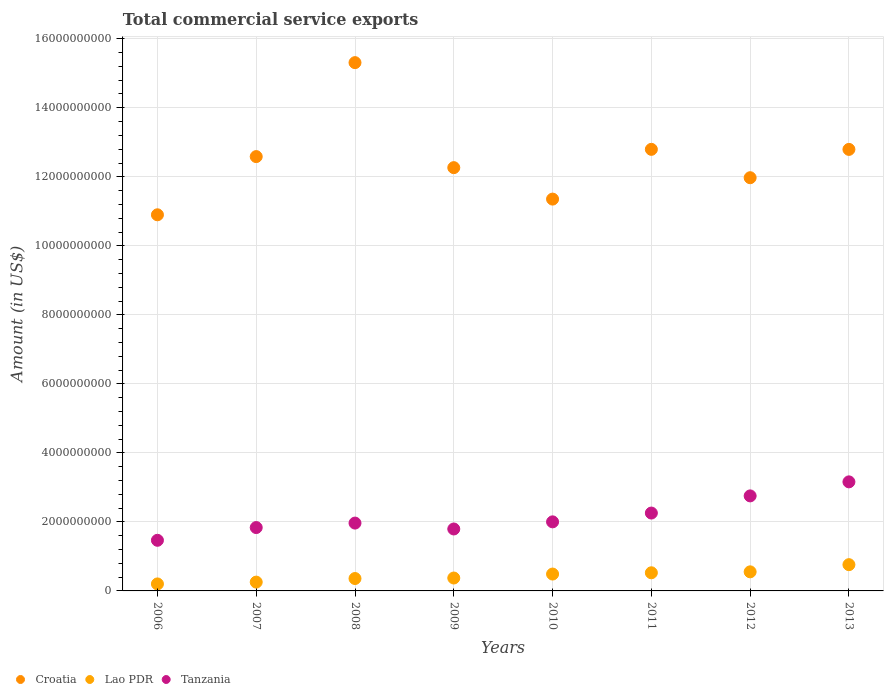Is the number of dotlines equal to the number of legend labels?
Keep it short and to the point. Yes. What is the total commercial service exports in Croatia in 2010?
Keep it short and to the point. 1.14e+1. Across all years, what is the maximum total commercial service exports in Lao PDR?
Offer a terse response. 7.61e+08. Across all years, what is the minimum total commercial service exports in Lao PDR?
Make the answer very short. 2.03e+08. In which year was the total commercial service exports in Lao PDR maximum?
Your answer should be very brief. 2013. In which year was the total commercial service exports in Tanzania minimum?
Your answer should be very brief. 2006. What is the total total commercial service exports in Tanzania in the graph?
Offer a very short reply. 1.72e+1. What is the difference between the total commercial service exports in Lao PDR in 2008 and that in 2010?
Keep it short and to the point. -1.29e+08. What is the difference between the total commercial service exports in Tanzania in 2007 and the total commercial service exports in Lao PDR in 2009?
Provide a short and direct response. 1.46e+09. What is the average total commercial service exports in Croatia per year?
Your answer should be very brief. 1.25e+1. In the year 2012, what is the difference between the total commercial service exports in Lao PDR and total commercial service exports in Croatia?
Offer a terse response. -1.14e+1. What is the ratio of the total commercial service exports in Tanzania in 2009 to that in 2010?
Offer a terse response. 0.9. Is the difference between the total commercial service exports in Lao PDR in 2006 and 2013 greater than the difference between the total commercial service exports in Croatia in 2006 and 2013?
Keep it short and to the point. Yes. What is the difference between the highest and the second highest total commercial service exports in Lao PDR?
Offer a terse response. 2.08e+08. What is the difference between the highest and the lowest total commercial service exports in Lao PDR?
Your response must be concise. 5.58e+08. Is the sum of the total commercial service exports in Lao PDR in 2006 and 2008 greater than the maximum total commercial service exports in Croatia across all years?
Give a very brief answer. No. Is it the case that in every year, the sum of the total commercial service exports in Croatia and total commercial service exports in Lao PDR  is greater than the total commercial service exports in Tanzania?
Keep it short and to the point. Yes. Is the total commercial service exports in Lao PDR strictly greater than the total commercial service exports in Croatia over the years?
Offer a very short reply. No. Is the total commercial service exports in Croatia strictly less than the total commercial service exports in Tanzania over the years?
Offer a very short reply. No. How many years are there in the graph?
Keep it short and to the point. 8. Are the values on the major ticks of Y-axis written in scientific E-notation?
Your response must be concise. No. Does the graph contain any zero values?
Offer a terse response. No. Does the graph contain grids?
Provide a short and direct response. Yes. What is the title of the graph?
Offer a very short reply. Total commercial service exports. What is the label or title of the X-axis?
Give a very brief answer. Years. What is the Amount (in US$) of Croatia in 2006?
Offer a very short reply. 1.09e+1. What is the Amount (in US$) of Lao PDR in 2006?
Offer a very short reply. 2.03e+08. What is the Amount (in US$) in Tanzania in 2006?
Provide a short and direct response. 1.47e+09. What is the Amount (in US$) of Croatia in 2007?
Keep it short and to the point. 1.26e+1. What is the Amount (in US$) in Lao PDR in 2007?
Offer a very short reply. 2.55e+08. What is the Amount (in US$) in Tanzania in 2007?
Give a very brief answer. 1.84e+09. What is the Amount (in US$) in Croatia in 2008?
Offer a terse response. 1.53e+1. What is the Amount (in US$) of Lao PDR in 2008?
Keep it short and to the point. 3.59e+08. What is the Amount (in US$) in Tanzania in 2008?
Your answer should be very brief. 1.97e+09. What is the Amount (in US$) in Croatia in 2009?
Provide a succinct answer. 1.23e+1. What is the Amount (in US$) in Lao PDR in 2009?
Your response must be concise. 3.74e+08. What is the Amount (in US$) in Tanzania in 2009?
Keep it short and to the point. 1.79e+09. What is the Amount (in US$) of Croatia in 2010?
Offer a terse response. 1.14e+1. What is the Amount (in US$) of Lao PDR in 2010?
Give a very brief answer. 4.89e+08. What is the Amount (in US$) of Tanzania in 2010?
Provide a succinct answer. 2.00e+09. What is the Amount (in US$) of Croatia in 2011?
Provide a short and direct response. 1.28e+1. What is the Amount (in US$) of Lao PDR in 2011?
Give a very brief answer. 5.26e+08. What is the Amount (in US$) of Tanzania in 2011?
Ensure brevity in your answer.  2.26e+09. What is the Amount (in US$) in Croatia in 2012?
Offer a terse response. 1.20e+1. What is the Amount (in US$) of Lao PDR in 2012?
Your answer should be compact. 5.53e+08. What is the Amount (in US$) in Tanzania in 2012?
Your response must be concise. 2.75e+09. What is the Amount (in US$) in Croatia in 2013?
Give a very brief answer. 1.28e+1. What is the Amount (in US$) in Lao PDR in 2013?
Provide a succinct answer. 7.61e+08. What is the Amount (in US$) in Tanzania in 2013?
Keep it short and to the point. 3.16e+09. Across all years, what is the maximum Amount (in US$) in Croatia?
Provide a succinct answer. 1.53e+1. Across all years, what is the maximum Amount (in US$) of Lao PDR?
Keep it short and to the point. 7.61e+08. Across all years, what is the maximum Amount (in US$) of Tanzania?
Offer a very short reply. 3.16e+09. Across all years, what is the minimum Amount (in US$) of Croatia?
Provide a succinct answer. 1.09e+1. Across all years, what is the minimum Amount (in US$) of Lao PDR?
Give a very brief answer. 2.03e+08. Across all years, what is the minimum Amount (in US$) of Tanzania?
Your response must be concise. 1.47e+09. What is the total Amount (in US$) in Croatia in the graph?
Provide a succinct answer. 1.00e+11. What is the total Amount (in US$) in Lao PDR in the graph?
Keep it short and to the point. 3.52e+09. What is the total Amount (in US$) in Tanzania in the graph?
Your answer should be very brief. 1.72e+1. What is the difference between the Amount (in US$) of Croatia in 2006 and that in 2007?
Keep it short and to the point. -1.69e+09. What is the difference between the Amount (in US$) in Lao PDR in 2006 and that in 2007?
Offer a very short reply. -5.27e+07. What is the difference between the Amount (in US$) in Tanzania in 2006 and that in 2007?
Your answer should be very brief. -3.69e+08. What is the difference between the Amount (in US$) in Croatia in 2006 and that in 2008?
Provide a short and direct response. -4.41e+09. What is the difference between the Amount (in US$) in Lao PDR in 2006 and that in 2008?
Keep it short and to the point. -1.57e+08. What is the difference between the Amount (in US$) of Tanzania in 2006 and that in 2008?
Provide a short and direct response. -4.99e+08. What is the difference between the Amount (in US$) in Croatia in 2006 and that in 2009?
Offer a very short reply. -1.37e+09. What is the difference between the Amount (in US$) in Lao PDR in 2006 and that in 2009?
Your response must be concise. -1.71e+08. What is the difference between the Amount (in US$) in Tanzania in 2006 and that in 2009?
Your answer should be compact. -3.28e+08. What is the difference between the Amount (in US$) in Croatia in 2006 and that in 2010?
Make the answer very short. -4.55e+08. What is the difference between the Amount (in US$) in Lao PDR in 2006 and that in 2010?
Provide a short and direct response. -2.86e+08. What is the difference between the Amount (in US$) of Tanzania in 2006 and that in 2010?
Give a very brief answer. -5.34e+08. What is the difference between the Amount (in US$) of Croatia in 2006 and that in 2011?
Ensure brevity in your answer.  -1.90e+09. What is the difference between the Amount (in US$) of Lao PDR in 2006 and that in 2011?
Ensure brevity in your answer.  -3.23e+08. What is the difference between the Amount (in US$) in Tanzania in 2006 and that in 2011?
Provide a short and direct response. -7.89e+08. What is the difference between the Amount (in US$) in Croatia in 2006 and that in 2012?
Make the answer very short. -1.07e+09. What is the difference between the Amount (in US$) in Lao PDR in 2006 and that in 2012?
Offer a very short reply. -3.50e+08. What is the difference between the Amount (in US$) in Tanzania in 2006 and that in 2012?
Offer a very short reply. -1.29e+09. What is the difference between the Amount (in US$) in Croatia in 2006 and that in 2013?
Your answer should be very brief. -1.90e+09. What is the difference between the Amount (in US$) in Lao PDR in 2006 and that in 2013?
Keep it short and to the point. -5.58e+08. What is the difference between the Amount (in US$) of Tanzania in 2006 and that in 2013?
Offer a terse response. -1.69e+09. What is the difference between the Amount (in US$) of Croatia in 2007 and that in 2008?
Offer a very short reply. -2.72e+09. What is the difference between the Amount (in US$) in Lao PDR in 2007 and that in 2008?
Offer a very short reply. -1.04e+08. What is the difference between the Amount (in US$) of Tanzania in 2007 and that in 2008?
Offer a terse response. -1.29e+08. What is the difference between the Amount (in US$) of Croatia in 2007 and that in 2009?
Your response must be concise. 3.20e+08. What is the difference between the Amount (in US$) in Lao PDR in 2007 and that in 2009?
Provide a short and direct response. -1.19e+08. What is the difference between the Amount (in US$) in Tanzania in 2007 and that in 2009?
Ensure brevity in your answer.  4.15e+07. What is the difference between the Amount (in US$) of Croatia in 2007 and that in 2010?
Offer a very short reply. 1.23e+09. What is the difference between the Amount (in US$) of Lao PDR in 2007 and that in 2010?
Ensure brevity in your answer.  -2.33e+08. What is the difference between the Amount (in US$) of Tanzania in 2007 and that in 2010?
Keep it short and to the point. -1.65e+08. What is the difference between the Amount (in US$) in Croatia in 2007 and that in 2011?
Offer a terse response. -2.10e+08. What is the difference between the Amount (in US$) of Lao PDR in 2007 and that in 2011?
Your answer should be compact. -2.70e+08. What is the difference between the Amount (in US$) in Tanzania in 2007 and that in 2011?
Provide a succinct answer. -4.20e+08. What is the difference between the Amount (in US$) of Croatia in 2007 and that in 2012?
Keep it short and to the point. 6.12e+08. What is the difference between the Amount (in US$) in Lao PDR in 2007 and that in 2012?
Your answer should be very brief. -2.98e+08. What is the difference between the Amount (in US$) of Tanzania in 2007 and that in 2012?
Make the answer very short. -9.17e+08. What is the difference between the Amount (in US$) of Croatia in 2007 and that in 2013?
Give a very brief answer. -2.09e+08. What is the difference between the Amount (in US$) of Lao PDR in 2007 and that in 2013?
Ensure brevity in your answer.  -5.06e+08. What is the difference between the Amount (in US$) in Tanzania in 2007 and that in 2013?
Keep it short and to the point. -1.32e+09. What is the difference between the Amount (in US$) of Croatia in 2008 and that in 2009?
Give a very brief answer. 3.04e+09. What is the difference between the Amount (in US$) in Lao PDR in 2008 and that in 2009?
Ensure brevity in your answer.  -1.45e+07. What is the difference between the Amount (in US$) in Tanzania in 2008 and that in 2009?
Keep it short and to the point. 1.71e+08. What is the difference between the Amount (in US$) in Croatia in 2008 and that in 2010?
Make the answer very short. 3.95e+09. What is the difference between the Amount (in US$) in Lao PDR in 2008 and that in 2010?
Make the answer very short. -1.29e+08. What is the difference between the Amount (in US$) in Tanzania in 2008 and that in 2010?
Offer a terse response. -3.58e+07. What is the difference between the Amount (in US$) of Croatia in 2008 and that in 2011?
Offer a terse response. 2.51e+09. What is the difference between the Amount (in US$) in Lao PDR in 2008 and that in 2011?
Your answer should be compact. -1.66e+08. What is the difference between the Amount (in US$) in Tanzania in 2008 and that in 2011?
Ensure brevity in your answer.  -2.91e+08. What is the difference between the Amount (in US$) in Croatia in 2008 and that in 2012?
Provide a succinct answer. 3.33e+09. What is the difference between the Amount (in US$) in Lao PDR in 2008 and that in 2012?
Offer a terse response. -1.94e+08. What is the difference between the Amount (in US$) of Tanzania in 2008 and that in 2012?
Ensure brevity in your answer.  -7.88e+08. What is the difference between the Amount (in US$) in Croatia in 2008 and that in 2013?
Provide a succinct answer. 2.51e+09. What is the difference between the Amount (in US$) of Lao PDR in 2008 and that in 2013?
Provide a short and direct response. -4.02e+08. What is the difference between the Amount (in US$) in Tanzania in 2008 and that in 2013?
Keep it short and to the point. -1.19e+09. What is the difference between the Amount (in US$) of Croatia in 2009 and that in 2010?
Offer a very short reply. 9.11e+08. What is the difference between the Amount (in US$) in Lao PDR in 2009 and that in 2010?
Keep it short and to the point. -1.15e+08. What is the difference between the Amount (in US$) of Tanzania in 2009 and that in 2010?
Your answer should be compact. -2.07e+08. What is the difference between the Amount (in US$) of Croatia in 2009 and that in 2011?
Keep it short and to the point. -5.30e+08. What is the difference between the Amount (in US$) in Lao PDR in 2009 and that in 2011?
Provide a succinct answer. -1.52e+08. What is the difference between the Amount (in US$) of Tanzania in 2009 and that in 2011?
Your answer should be very brief. -4.62e+08. What is the difference between the Amount (in US$) of Croatia in 2009 and that in 2012?
Make the answer very short. 2.92e+08. What is the difference between the Amount (in US$) in Lao PDR in 2009 and that in 2012?
Give a very brief answer. -1.79e+08. What is the difference between the Amount (in US$) in Tanzania in 2009 and that in 2012?
Make the answer very short. -9.59e+08. What is the difference between the Amount (in US$) in Croatia in 2009 and that in 2013?
Offer a terse response. -5.29e+08. What is the difference between the Amount (in US$) in Lao PDR in 2009 and that in 2013?
Ensure brevity in your answer.  -3.87e+08. What is the difference between the Amount (in US$) of Tanzania in 2009 and that in 2013?
Offer a very short reply. -1.37e+09. What is the difference between the Amount (in US$) in Croatia in 2010 and that in 2011?
Offer a terse response. -1.44e+09. What is the difference between the Amount (in US$) in Lao PDR in 2010 and that in 2011?
Keep it short and to the point. -3.68e+07. What is the difference between the Amount (in US$) of Tanzania in 2010 and that in 2011?
Your answer should be very brief. -2.55e+08. What is the difference between the Amount (in US$) of Croatia in 2010 and that in 2012?
Offer a terse response. -6.20e+08. What is the difference between the Amount (in US$) in Lao PDR in 2010 and that in 2012?
Your answer should be very brief. -6.41e+07. What is the difference between the Amount (in US$) in Tanzania in 2010 and that in 2012?
Your answer should be compact. -7.52e+08. What is the difference between the Amount (in US$) of Croatia in 2010 and that in 2013?
Offer a very short reply. -1.44e+09. What is the difference between the Amount (in US$) in Lao PDR in 2010 and that in 2013?
Give a very brief answer. -2.72e+08. What is the difference between the Amount (in US$) of Tanzania in 2010 and that in 2013?
Offer a terse response. -1.16e+09. What is the difference between the Amount (in US$) of Croatia in 2011 and that in 2012?
Make the answer very short. 8.22e+08. What is the difference between the Amount (in US$) of Lao PDR in 2011 and that in 2012?
Offer a terse response. -2.74e+07. What is the difference between the Amount (in US$) of Tanzania in 2011 and that in 2012?
Offer a very short reply. -4.97e+08. What is the difference between the Amount (in US$) in Croatia in 2011 and that in 2013?
Keep it short and to the point. 1.49e+06. What is the difference between the Amount (in US$) of Lao PDR in 2011 and that in 2013?
Your answer should be compact. -2.35e+08. What is the difference between the Amount (in US$) in Tanzania in 2011 and that in 2013?
Your answer should be compact. -9.04e+08. What is the difference between the Amount (in US$) of Croatia in 2012 and that in 2013?
Offer a very short reply. -8.21e+08. What is the difference between the Amount (in US$) in Lao PDR in 2012 and that in 2013?
Keep it short and to the point. -2.08e+08. What is the difference between the Amount (in US$) of Tanzania in 2012 and that in 2013?
Your answer should be compact. -4.07e+08. What is the difference between the Amount (in US$) in Croatia in 2006 and the Amount (in US$) in Lao PDR in 2007?
Give a very brief answer. 1.06e+1. What is the difference between the Amount (in US$) in Croatia in 2006 and the Amount (in US$) in Tanzania in 2007?
Provide a succinct answer. 9.06e+09. What is the difference between the Amount (in US$) of Lao PDR in 2006 and the Amount (in US$) of Tanzania in 2007?
Make the answer very short. -1.63e+09. What is the difference between the Amount (in US$) of Croatia in 2006 and the Amount (in US$) of Lao PDR in 2008?
Provide a short and direct response. 1.05e+1. What is the difference between the Amount (in US$) in Croatia in 2006 and the Amount (in US$) in Tanzania in 2008?
Your response must be concise. 8.93e+09. What is the difference between the Amount (in US$) in Lao PDR in 2006 and the Amount (in US$) in Tanzania in 2008?
Make the answer very short. -1.76e+09. What is the difference between the Amount (in US$) in Croatia in 2006 and the Amount (in US$) in Lao PDR in 2009?
Your answer should be compact. 1.05e+1. What is the difference between the Amount (in US$) in Croatia in 2006 and the Amount (in US$) in Tanzania in 2009?
Offer a terse response. 9.10e+09. What is the difference between the Amount (in US$) of Lao PDR in 2006 and the Amount (in US$) of Tanzania in 2009?
Offer a terse response. -1.59e+09. What is the difference between the Amount (in US$) in Croatia in 2006 and the Amount (in US$) in Lao PDR in 2010?
Your answer should be very brief. 1.04e+1. What is the difference between the Amount (in US$) in Croatia in 2006 and the Amount (in US$) in Tanzania in 2010?
Offer a terse response. 8.90e+09. What is the difference between the Amount (in US$) of Lao PDR in 2006 and the Amount (in US$) of Tanzania in 2010?
Your answer should be compact. -1.80e+09. What is the difference between the Amount (in US$) of Croatia in 2006 and the Amount (in US$) of Lao PDR in 2011?
Provide a succinct answer. 1.04e+1. What is the difference between the Amount (in US$) of Croatia in 2006 and the Amount (in US$) of Tanzania in 2011?
Your answer should be compact. 8.64e+09. What is the difference between the Amount (in US$) of Lao PDR in 2006 and the Amount (in US$) of Tanzania in 2011?
Offer a very short reply. -2.05e+09. What is the difference between the Amount (in US$) of Croatia in 2006 and the Amount (in US$) of Lao PDR in 2012?
Give a very brief answer. 1.03e+1. What is the difference between the Amount (in US$) of Croatia in 2006 and the Amount (in US$) of Tanzania in 2012?
Ensure brevity in your answer.  8.15e+09. What is the difference between the Amount (in US$) in Lao PDR in 2006 and the Amount (in US$) in Tanzania in 2012?
Your answer should be compact. -2.55e+09. What is the difference between the Amount (in US$) in Croatia in 2006 and the Amount (in US$) in Lao PDR in 2013?
Offer a very short reply. 1.01e+1. What is the difference between the Amount (in US$) of Croatia in 2006 and the Amount (in US$) of Tanzania in 2013?
Your answer should be very brief. 7.74e+09. What is the difference between the Amount (in US$) of Lao PDR in 2006 and the Amount (in US$) of Tanzania in 2013?
Ensure brevity in your answer.  -2.96e+09. What is the difference between the Amount (in US$) of Croatia in 2007 and the Amount (in US$) of Lao PDR in 2008?
Provide a short and direct response. 1.22e+1. What is the difference between the Amount (in US$) in Croatia in 2007 and the Amount (in US$) in Tanzania in 2008?
Give a very brief answer. 1.06e+1. What is the difference between the Amount (in US$) in Lao PDR in 2007 and the Amount (in US$) in Tanzania in 2008?
Ensure brevity in your answer.  -1.71e+09. What is the difference between the Amount (in US$) of Croatia in 2007 and the Amount (in US$) of Lao PDR in 2009?
Give a very brief answer. 1.22e+1. What is the difference between the Amount (in US$) in Croatia in 2007 and the Amount (in US$) in Tanzania in 2009?
Your response must be concise. 1.08e+1. What is the difference between the Amount (in US$) of Lao PDR in 2007 and the Amount (in US$) of Tanzania in 2009?
Keep it short and to the point. -1.54e+09. What is the difference between the Amount (in US$) in Croatia in 2007 and the Amount (in US$) in Lao PDR in 2010?
Give a very brief answer. 1.21e+1. What is the difference between the Amount (in US$) in Croatia in 2007 and the Amount (in US$) in Tanzania in 2010?
Provide a short and direct response. 1.06e+1. What is the difference between the Amount (in US$) in Lao PDR in 2007 and the Amount (in US$) in Tanzania in 2010?
Provide a short and direct response. -1.75e+09. What is the difference between the Amount (in US$) of Croatia in 2007 and the Amount (in US$) of Lao PDR in 2011?
Give a very brief answer. 1.21e+1. What is the difference between the Amount (in US$) of Croatia in 2007 and the Amount (in US$) of Tanzania in 2011?
Make the answer very short. 1.03e+1. What is the difference between the Amount (in US$) in Lao PDR in 2007 and the Amount (in US$) in Tanzania in 2011?
Your answer should be compact. -2.00e+09. What is the difference between the Amount (in US$) of Croatia in 2007 and the Amount (in US$) of Lao PDR in 2012?
Give a very brief answer. 1.20e+1. What is the difference between the Amount (in US$) in Croatia in 2007 and the Amount (in US$) in Tanzania in 2012?
Your answer should be very brief. 9.83e+09. What is the difference between the Amount (in US$) of Lao PDR in 2007 and the Amount (in US$) of Tanzania in 2012?
Give a very brief answer. -2.50e+09. What is the difference between the Amount (in US$) in Croatia in 2007 and the Amount (in US$) in Lao PDR in 2013?
Make the answer very short. 1.18e+1. What is the difference between the Amount (in US$) of Croatia in 2007 and the Amount (in US$) of Tanzania in 2013?
Keep it short and to the point. 9.43e+09. What is the difference between the Amount (in US$) of Lao PDR in 2007 and the Amount (in US$) of Tanzania in 2013?
Your response must be concise. -2.90e+09. What is the difference between the Amount (in US$) of Croatia in 2008 and the Amount (in US$) of Lao PDR in 2009?
Provide a short and direct response. 1.49e+1. What is the difference between the Amount (in US$) in Croatia in 2008 and the Amount (in US$) in Tanzania in 2009?
Ensure brevity in your answer.  1.35e+1. What is the difference between the Amount (in US$) in Lao PDR in 2008 and the Amount (in US$) in Tanzania in 2009?
Make the answer very short. -1.44e+09. What is the difference between the Amount (in US$) of Croatia in 2008 and the Amount (in US$) of Lao PDR in 2010?
Provide a short and direct response. 1.48e+1. What is the difference between the Amount (in US$) in Croatia in 2008 and the Amount (in US$) in Tanzania in 2010?
Give a very brief answer. 1.33e+1. What is the difference between the Amount (in US$) in Lao PDR in 2008 and the Amount (in US$) in Tanzania in 2010?
Make the answer very short. -1.64e+09. What is the difference between the Amount (in US$) in Croatia in 2008 and the Amount (in US$) in Lao PDR in 2011?
Provide a short and direct response. 1.48e+1. What is the difference between the Amount (in US$) in Croatia in 2008 and the Amount (in US$) in Tanzania in 2011?
Offer a very short reply. 1.31e+1. What is the difference between the Amount (in US$) of Lao PDR in 2008 and the Amount (in US$) of Tanzania in 2011?
Provide a short and direct response. -1.90e+09. What is the difference between the Amount (in US$) of Croatia in 2008 and the Amount (in US$) of Lao PDR in 2012?
Your answer should be compact. 1.48e+1. What is the difference between the Amount (in US$) in Croatia in 2008 and the Amount (in US$) in Tanzania in 2012?
Provide a short and direct response. 1.26e+1. What is the difference between the Amount (in US$) in Lao PDR in 2008 and the Amount (in US$) in Tanzania in 2012?
Keep it short and to the point. -2.39e+09. What is the difference between the Amount (in US$) of Croatia in 2008 and the Amount (in US$) of Lao PDR in 2013?
Ensure brevity in your answer.  1.45e+1. What is the difference between the Amount (in US$) of Croatia in 2008 and the Amount (in US$) of Tanzania in 2013?
Offer a terse response. 1.21e+1. What is the difference between the Amount (in US$) of Lao PDR in 2008 and the Amount (in US$) of Tanzania in 2013?
Give a very brief answer. -2.80e+09. What is the difference between the Amount (in US$) of Croatia in 2009 and the Amount (in US$) of Lao PDR in 2010?
Provide a short and direct response. 1.18e+1. What is the difference between the Amount (in US$) in Croatia in 2009 and the Amount (in US$) in Tanzania in 2010?
Make the answer very short. 1.03e+1. What is the difference between the Amount (in US$) of Lao PDR in 2009 and the Amount (in US$) of Tanzania in 2010?
Provide a succinct answer. -1.63e+09. What is the difference between the Amount (in US$) in Croatia in 2009 and the Amount (in US$) in Lao PDR in 2011?
Give a very brief answer. 1.17e+1. What is the difference between the Amount (in US$) in Croatia in 2009 and the Amount (in US$) in Tanzania in 2011?
Offer a terse response. 1.00e+1. What is the difference between the Amount (in US$) of Lao PDR in 2009 and the Amount (in US$) of Tanzania in 2011?
Keep it short and to the point. -1.88e+09. What is the difference between the Amount (in US$) in Croatia in 2009 and the Amount (in US$) in Lao PDR in 2012?
Offer a terse response. 1.17e+1. What is the difference between the Amount (in US$) of Croatia in 2009 and the Amount (in US$) of Tanzania in 2012?
Your answer should be very brief. 9.51e+09. What is the difference between the Amount (in US$) in Lao PDR in 2009 and the Amount (in US$) in Tanzania in 2012?
Offer a very short reply. -2.38e+09. What is the difference between the Amount (in US$) of Croatia in 2009 and the Amount (in US$) of Lao PDR in 2013?
Offer a terse response. 1.15e+1. What is the difference between the Amount (in US$) of Croatia in 2009 and the Amount (in US$) of Tanzania in 2013?
Your answer should be very brief. 9.11e+09. What is the difference between the Amount (in US$) in Lao PDR in 2009 and the Amount (in US$) in Tanzania in 2013?
Offer a very short reply. -2.79e+09. What is the difference between the Amount (in US$) of Croatia in 2010 and the Amount (in US$) of Lao PDR in 2011?
Ensure brevity in your answer.  1.08e+1. What is the difference between the Amount (in US$) in Croatia in 2010 and the Amount (in US$) in Tanzania in 2011?
Offer a terse response. 9.10e+09. What is the difference between the Amount (in US$) in Lao PDR in 2010 and the Amount (in US$) in Tanzania in 2011?
Provide a short and direct response. -1.77e+09. What is the difference between the Amount (in US$) of Croatia in 2010 and the Amount (in US$) of Lao PDR in 2012?
Keep it short and to the point. 1.08e+1. What is the difference between the Amount (in US$) in Croatia in 2010 and the Amount (in US$) in Tanzania in 2012?
Offer a very short reply. 8.60e+09. What is the difference between the Amount (in US$) in Lao PDR in 2010 and the Amount (in US$) in Tanzania in 2012?
Keep it short and to the point. -2.26e+09. What is the difference between the Amount (in US$) in Croatia in 2010 and the Amount (in US$) in Lao PDR in 2013?
Provide a succinct answer. 1.06e+1. What is the difference between the Amount (in US$) of Croatia in 2010 and the Amount (in US$) of Tanzania in 2013?
Offer a terse response. 8.19e+09. What is the difference between the Amount (in US$) of Lao PDR in 2010 and the Amount (in US$) of Tanzania in 2013?
Keep it short and to the point. -2.67e+09. What is the difference between the Amount (in US$) of Croatia in 2011 and the Amount (in US$) of Lao PDR in 2012?
Provide a succinct answer. 1.22e+1. What is the difference between the Amount (in US$) in Croatia in 2011 and the Amount (in US$) in Tanzania in 2012?
Give a very brief answer. 1.00e+1. What is the difference between the Amount (in US$) in Lao PDR in 2011 and the Amount (in US$) in Tanzania in 2012?
Your answer should be very brief. -2.23e+09. What is the difference between the Amount (in US$) in Croatia in 2011 and the Amount (in US$) in Lao PDR in 2013?
Keep it short and to the point. 1.20e+1. What is the difference between the Amount (in US$) in Croatia in 2011 and the Amount (in US$) in Tanzania in 2013?
Make the answer very short. 9.64e+09. What is the difference between the Amount (in US$) of Lao PDR in 2011 and the Amount (in US$) of Tanzania in 2013?
Your response must be concise. -2.63e+09. What is the difference between the Amount (in US$) of Croatia in 2012 and the Amount (in US$) of Lao PDR in 2013?
Provide a short and direct response. 1.12e+1. What is the difference between the Amount (in US$) of Croatia in 2012 and the Amount (in US$) of Tanzania in 2013?
Keep it short and to the point. 8.81e+09. What is the difference between the Amount (in US$) in Lao PDR in 2012 and the Amount (in US$) in Tanzania in 2013?
Provide a succinct answer. -2.61e+09. What is the average Amount (in US$) in Croatia per year?
Keep it short and to the point. 1.25e+1. What is the average Amount (in US$) in Lao PDR per year?
Keep it short and to the point. 4.40e+08. What is the average Amount (in US$) in Tanzania per year?
Your answer should be very brief. 2.15e+09. In the year 2006, what is the difference between the Amount (in US$) in Croatia and Amount (in US$) in Lao PDR?
Provide a short and direct response. 1.07e+1. In the year 2006, what is the difference between the Amount (in US$) of Croatia and Amount (in US$) of Tanzania?
Provide a succinct answer. 9.43e+09. In the year 2006, what is the difference between the Amount (in US$) of Lao PDR and Amount (in US$) of Tanzania?
Your response must be concise. -1.26e+09. In the year 2007, what is the difference between the Amount (in US$) in Croatia and Amount (in US$) in Lao PDR?
Offer a terse response. 1.23e+1. In the year 2007, what is the difference between the Amount (in US$) in Croatia and Amount (in US$) in Tanzania?
Offer a very short reply. 1.07e+1. In the year 2007, what is the difference between the Amount (in US$) of Lao PDR and Amount (in US$) of Tanzania?
Give a very brief answer. -1.58e+09. In the year 2008, what is the difference between the Amount (in US$) in Croatia and Amount (in US$) in Lao PDR?
Provide a short and direct response. 1.49e+1. In the year 2008, what is the difference between the Amount (in US$) in Croatia and Amount (in US$) in Tanzania?
Make the answer very short. 1.33e+1. In the year 2008, what is the difference between the Amount (in US$) of Lao PDR and Amount (in US$) of Tanzania?
Offer a terse response. -1.61e+09. In the year 2009, what is the difference between the Amount (in US$) of Croatia and Amount (in US$) of Lao PDR?
Offer a terse response. 1.19e+1. In the year 2009, what is the difference between the Amount (in US$) of Croatia and Amount (in US$) of Tanzania?
Keep it short and to the point. 1.05e+1. In the year 2009, what is the difference between the Amount (in US$) in Lao PDR and Amount (in US$) in Tanzania?
Make the answer very short. -1.42e+09. In the year 2010, what is the difference between the Amount (in US$) in Croatia and Amount (in US$) in Lao PDR?
Your answer should be very brief. 1.09e+1. In the year 2010, what is the difference between the Amount (in US$) of Croatia and Amount (in US$) of Tanzania?
Ensure brevity in your answer.  9.35e+09. In the year 2010, what is the difference between the Amount (in US$) of Lao PDR and Amount (in US$) of Tanzania?
Offer a very short reply. -1.51e+09. In the year 2011, what is the difference between the Amount (in US$) in Croatia and Amount (in US$) in Lao PDR?
Your response must be concise. 1.23e+1. In the year 2011, what is the difference between the Amount (in US$) in Croatia and Amount (in US$) in Tanzania?
Your answer should be very brief. 1.05e+1. In the year 2011, what is the difference between the Amount (in US$) in Lao PDR and Amount (in US$) in Tanzania?
Make the answer very short. -1.73e+09. In the year 2012, what is the difference between the Amount (in US$) in Croatia and Amount (in US$) in Lao PDR?
Your answer should be compact. 1.14e+1. In the year 2012, what is the difference between the Amount (in US$) of Croatia and Amount (in US$) of Tanzania?
Your response must be concise. 9.22e+09. In the year 2012, what is the difference between the Amount (in US$) in Lao PDR and Amount (in US$) in Tanzania?
Keep it short and to the point. -2.20e+09. In the year 2013, what is the difference between the Amount (in US$) in Croatia and Amount (in US$) in Lao PDR?
Provide a succinct answer. 1.20e+1. In the year 2013, what is the difference between the Amount (in US$) of Croatia and Amount (in US$) of Tanzania?
Offer a terse response. 9.63e+09. In the year 2013, what is the difference between the Amount (in US$) in Lao PDR and Amount (in US$) in Tanzania?
Make the answer very short. -2.40e+09. What is the ratio of the Amount (in US$) in Croatia in 2006 to that in 2007?
Offer a terse response. 0.87. What is the ratio of the Amount (in US$) in Lao PDR in 2006 to that in 2007?
Give a very brief answer. 0.79. What is the ratio of the Amount (in US$) of Tanzania in 2006 to that in 2007?
Your response must be concise. 0.8. What is the ratio of the Amount (in US$) in Croatia in 2006 to that in 2008?
Give a very brief answer. 0.71. What is the ratio of the Amount (in US$) in Lao PDR in 2006 to that in 2008?
Your answer should be compact. 0.56. What is the ratio of the Amount (in US$) in Tanzania in 2006 to that in 2008?
Make the answer very short. 0.75. What is the ratio of the Amount (in US$) in Croatia in 2006 to that in 2009?
Your response must be concise. 0.89. What is the ratio of the Amount (in US$) of Lao PDR in 2006 to that in 2009?
Offer a very short reply. 0.54. What is the ratio of the Amount (in US$) in Tanzania in 2006 to that in 2009?
Keep it short and to the point. 0.82. What is the ratio of the Amount (in US$) in Croatia in 2006 to that in 2010?
Your answer should be very brief. 0.96. What is the ratio of the Amount (in US$) of Lao PDR in 2006 to that in 2010?
Keep it short and to the point. 0.41. What is the ratio of the Amount (in US$) in Tanzania in 2006 to that in 2010?
Offer a terse response. 0.73. What is the ratio of the Amount (in US$) of Croatia in 2006 to that in 2011?
Offer a very short reply. 0.85. What is the ratio of the Amount (in US$) in Lao PDR in 2006 to that in 2011?
Make the answer very short. 0.39. What is the ratio of the Amount (in US$) in Tanzania in 2006 to that in 2011?
Offer a very short reply. 0.65. What is the ratio of the Amount (in US$) in Croatia in 2006 to that in 2012?
Provide a succinct answer. 0.91. What is the ratio of the Amount (in US$) in Lao PDR in 2006 to that in 2012?
Offer a very short reply. 0.37. What is the ratio of the Amount (in US$) in Tanzania in 2006 to that in 2012?
Offer a terse response. 0.53. What is the ratio of the Amount (in US$) in Croatia in 2006 to that in 2013?
Provide a short and direct response. 0.85. What is the ratio of the Amount (in US$) of Lao PDR in 2006 to that in 2013?
Provide a short and direct response. 0.27. What is the ratio of the Amount (in US$) of Tanzania in 2006 to that in 2013?
Ensure brevity in your answer.  0.46. What is the ratio of the Amount (in US$) in Croatia in 2007 to that in 2008?
Keep it short and to the point. 0.82. What is the ratio of the Amount (in US$) in Lao PDR in 2007 to that in 2008?
Ensure brevity in your answer.  0.71. What is the ratio of the Amount (in US$) of Tanzania in 2007 to that in 2008?
Give a very brief answer. 0.93. What is the ratio of the Amount (in US$) of Croatia in 2007 to that in 2009?
Offer a terse response. 1.03. What is the ratio of the Amount (in US$) of Lao PDR in 2007 to that in 2009?
Provide a short and direct response. 0.68. What is the ratio of the Amount (in US$) in Tanzania in 2007 to that in 2009?
Offer a terse response. 1.02. What is the ratio of the Amount (in US$) of Croatia in 2007 to that in 2010?
Keep it short and to the point. 1.11. What is the ratio of the Amount (in US$) in Lao PDR in 2007 to that in 2010?
Provide a succinct answer. 0.52. What is the ratio of the Amount (in US$) in Tanzania in 2007 to that in 2010?
Your response must be concise. 0.92. What is the ratio of the Amount (in US$) of Croatia in 2007 to that in 2011?
Keep it short and to the point. 0.98. What is the ratio of the Amount (in US$) in Lao PDR in 2007 to that in 2011?
Provide a short and direct response. 0.49. What is the ratio of the Amount (in US$) in Tanzania in 2007 to that in 2011?
Your response must be concise. 0.81. What is the ratio of the Amount (in US$) of Croatia in 2007 to that in 2012?
Offer a terse response. 1.05. What is the ratio of the Amount (in US$) in Lao PDR in 2007 to that in 2012?
Make the answer very short. 0.46. What is the ratio of the Amount (in US$) in Tanzania in 2007 to that in 2012?
Make the answer very short. 0.67. What is the ratio of the Amount (in US$) in Croatia in 2007 to that in 2013?
Offer a terse response. 0.98. What is the ratio of the Amount (in US$) in Lao PDR in 2007 to that in 2013?
Give a very brief answer. 0.34. What is the ratio of the Amount (in US$) of Tanzania in 2007 to that in 2013?
Make the answer very short. 0.58. What is the ratio of the Amount (in US$) in Croatia in 2008 to that in 2009?
Your answer should be very brief. 1.25. What is the ratio of the Amount (in US$) in Lao PDR in 2008 to that in 2009?
Ensure brevity in your answer.  0.96. What is the ratio of the Amount (in US$) of Tanzania in 2008 to that in 2009?
Your answer should be very brief. 1.1. What is the ratio of the Amount (in US$) in Croatia in 2008 to that in 2010?
Keep it short and to the point. 1.35. What is the ratio of the Amount (in US$) in Lao PDR in 2008 to that in 2010?
Give a very brief answer. 0.74. What is the ratio of the Amount (in US$) in Tanzania in 2008 to that in 2010?
Offer a very short reply. 0.98. What is the ratio of the Amount (in US$) of Croatia in 2008 to that in 2011?
Give a very brief answer. 1.2. What is the ratio of the Amount (in US$) of Lao PDR in 2008 to that in 2011?
Provide a succinct answer. 0.68. What is the ratio of the Amount (in US$) in Tanzania in 2008 to that in 2011?
Ensure brevity in your answer.  0.87. What is the ratio of the Amount (in US$) of Croatia in 2008 to that in 2012?
Give a very brief answer. 1.28. What is the ratio of the Amount (in US$) of Lao PDR in 2008 to that in 2012?
Your response must be concise. 0.65. What is the ratio of the Amount (in US$) in Tanzania in 2008 to that in 2012?
Your answer should be compact. 0.71. What is the ratio of the Amount (in US$) in Croatia in 2008 to that in 2013?
Your response must be concise. 1.2. What is the ratio of the Amount (in US$) of Lao PDR in 2008 to that in 2013?
Your response must be concise. 0.47. What is the ratio of the Amount (in US$) in Tanzania in 2008 to that in 2013?
Make the answer very short. 0.62. What is the ratio of the Amount (in US$) of Croatia in 2009 to that in 2010?
Your answer should be very brief. 1.08. What is the ratio of the Amount (in US$) of Lao PDR in 2009 to that in 2010?
Offer a very short reply. 0.77. What is the ratio of the Amount (in US$) in Tanzania in 2009 to that in 2010?
Give a very brief answer. 0.9. What is the ratio of the Amount (in US$) in Croatia in 2009 to that in 2011?
Your answer should be compact. 0.96. What is the ratio of the Amount (in US$) of Lao PDR in 2009 to that in 2011?
Make the answer very short. 0.71. What is the ratio of the Amount (in US$) in Tanzania in 2009 to that in 2011?
Keep it short and to the point. 0.8. What is the ratio of the Amount (in US$) of Croatia in 2009 to that in 2012?
Offer a terse response. 1.02. What is the ratio of the Amount (in US$) in Lao PDR in 2009 to that in 2012?
Ensure brevity in your answer.  0.68. What is the ratio of the Amount (in US$) in Tanzania in 2009 to that in 2012?
Give a very brief answer. 0.65. What is the ratio of the Amount (in US$) of Croatia in 2009 to that in 2013?
Provide a succinct answer. 0.96. What is the ratio of the Amount (in US$) in Lao PDR in 2009 to that in 2013?
Offer a very short reply. 0.49. What is the ratio of the Amount (in US$) in Tanzania in 2009 to that in 2013?
Provide a short and direct response. 0.57. What is the ratio of the Amount (in US$) of Croatia in 2010 to that in 2011?
Your answer should be very brief. 0.89. What is the ratio of the Amount (in US$) in Tanzania in 2010 to that in 2011?
Your answer should be compact. 0.89. What is the ratio of the Amount (in US$) in Croatia in 2010 to that in 2012?
Make the answer very short. 0.95. What is the ratio of the Amount (in US$) of Lao PDR in 2010 to that in 2012?
Keep it short and to the point. 0.88. What is the ratio of the Amount (in US$) of Tanzania in 2010 to that in 2012?
Make the answer very short. 0.73. What is the ratio of the Amount (in US$) in Croatia in 2010 to that in 2013?
Your response must be concise. 0.89. What is the ratio of the Amount (in US$) in Lao PDR in 2010 to that in 2013?
Give a very brief answer. 0.64. What is the ratio of the Amount (in US$) in Tanzania in 2010 to that in 2013?
Offer a terse response. 0.63. What is the ratio of the Amount (in US$) in Croatia in 2011 to that in 2012?
Provide a succinct answer. 1.07. What is the ratio of the Amount (in US$) of Lao PDR in 2011 to that in 2012?
Ensure brevity in your answer.  0.95. What is the ratio of the Amount (in US$) in Tanzania in 2011 to that in 2012?
Keep it short and to the point. 0.82. What is the ratio of the Amount (in US$) of Croatia in 2011 to that in 2013?
Keep it short and to the point. 1. What is the ratio of the Amount (in US$) in Lao PDR in 2011 to that in 2013?
Provide a short and direct response. 0.69. What is the ratio of the Amount (in US$) of Tanzania in 2011 to that in 2013?
Your answer should be compact. 0.71. What is the ratio of the Amount (in US$) in Croatia in 2012 to that in 2013?
Ensure brevity in your answer.  0.94. What is the ratio of the Amount (in US$) of Lao PDR in 2012 to that in 2013?
Your answer should be very brief. 0.73. What is the ratio of the Amount (in US$) of Tanzania in 2012 to that in 2013?
Your response must be concise. 0.87. What is the difference between the highest and the second highest Amount (in US$) of Croatia?
Provide a succinct answer. 2.51e+09. What is the difference between the highest and the second highest Amount (in US$) of Lao PDR?
Provide a succinct answer. 2.08e+08. What is the difference between the highest and the second highest Amount (in US$) of Tanzania?
Offer a very short reply. 4.07e+08. What is the difference between the highest and the lowest Amount (in US$) of Croatia?
Your answer should be very brief. 4.41e+09. What is the difference between the highest and the lowest Amount (in US$) in Lao PDR?
Give a very brief answer. 5.58e+08. What is the difference between the highest and the lowest Amount (in US$) in Tanzania?
Provide a succinct answer. 1.69e+09. 